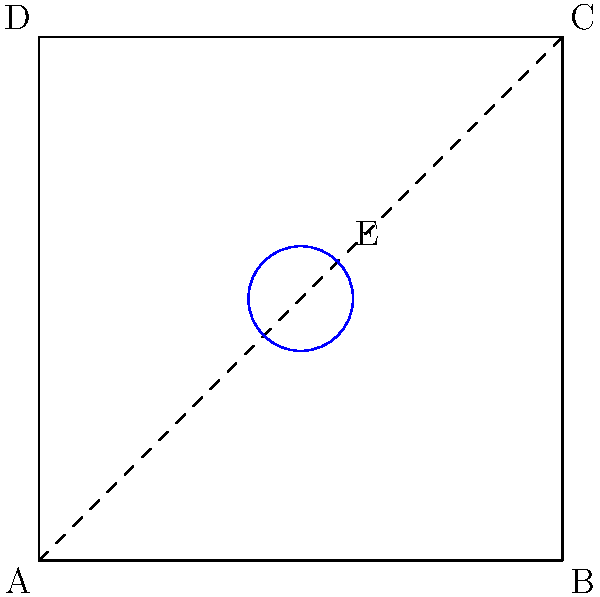After a disappointing loss at Allen Fieldhouse, you're analyzing the court layout. The diagram shows a simplified version of the court, with point E representing center court. If the entire court is reflected across the diagonal line AC, what will be the coordinates of the reflected center court point E'? Let's approach this step-by-step:

1) The original coordinates of point E are (5,5).

2) To reflect a point across a diagonal line, we can use the following method:
   - Swap the x and y coordinates
   - The new point will have the same y-coordinate as the original x, and the same x-coordinate as the original y

3) So, for point E(5,5):
   - The new x-coordinate will be 5 (the original y-coordinate)
   - The new y-coordinate will be 5 (the original x-coordinate)

4) Therefore, after reflection, the coordinates of E' will still be (5,5).

This result makes sense geometrically because the center point of a square lies on its diagonal, and reflecting a point that's already on the line of reflection doesn't change its position.
Answer: $(5,5)$ 